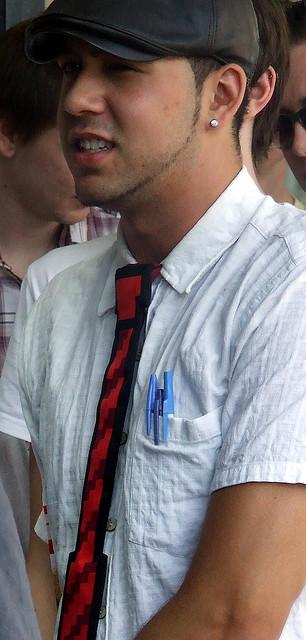What company is known for making the objects in the man's pocket?

Choices:
A) bic
B) dell
C) ibm
D) chipotle bic 